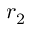Convert formula to latex. <formula><loc_0><loc_0><loc_500><loc_500>r _ { 2 }</formula> 